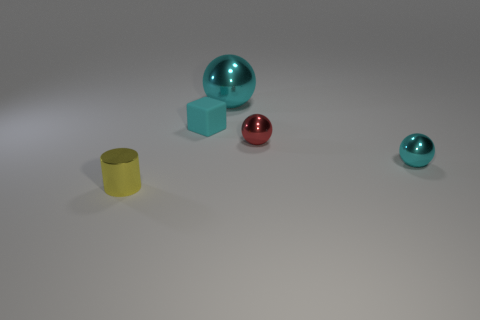Is there a yellow object?
Give a very brief answer. Yes. Do the small rubber block and the large shiny sphere have the same color?
Provide a succinct answer. Yes. How many large things are blue objects or yellow cylinders?
Give a very brief answer. 0. Is there anything else of the same color as the tiny rubber thing?
Make the answer very short. Yes. There is a large cyan object that is made of the same material as the cylinder; what is its shape?
Provide a short and direct response. Sphere. How big is the shiny ball that is right of the small red thing?
Provide a succinct answer. Small. The tiny matte object has what shape?
Offer a very short reply. Cube. Is the size of the cyan metallic object in front of the large ball the same as the block that is on the left side of the red sphere?
Provide a succinct answer. Yes. What is the size of the cyan sphere that is on the left side of the cyan shiny ball in front of the cyan ball that is behind the rubber thing?
Keep it short and to the point. Large. There is a object left of the small cyan thing on the left side of the cyan sphere that is in front of the big cyan shiny sphere; what shape is it?
Your answer should be very brief. Cylinder. 